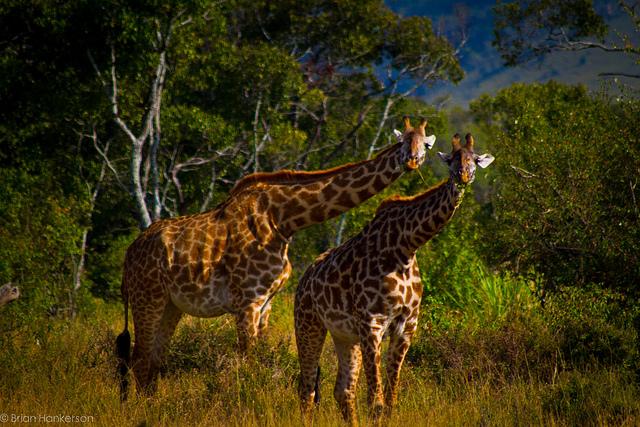Which giraffe is facing a different direction?
Short answer required. Neither. How much do these animal weight?
Short answer required. Unknown. What is the giraffe eating?
Keep it brief. Leaves. Are these animals all adults?
Concise answer only. Yes. Which giraffe is taller?
Be succinct. Left. Do these animals travel in herds?
Answer briefly. Yes. Is it nighttime?
Concise answer only. No. What animals are depicted in this photo?
Concise answer only. Giraffes. What is surrounding the giraffe?
Write a very short answer. Trees. Is this giraffe in the wild?
Give a very brief answer. Yes. How many giraffes are there?
Write a very short answer. 2. Are both giraffes standing?
Concise answer only. Yes. How many giraffes are in the picture?
Be succinct. 2. Are both giraffes looking in the same direction?
Keep it brief. Yes. Are the animals in a zoo?
Be succinct. No. Are the giraffes facing the same direction?
Be succinct. Yes. Are these animals looking at the photographer?
Short answer required. Yes. How many animals?
Keep it brief. 2. 